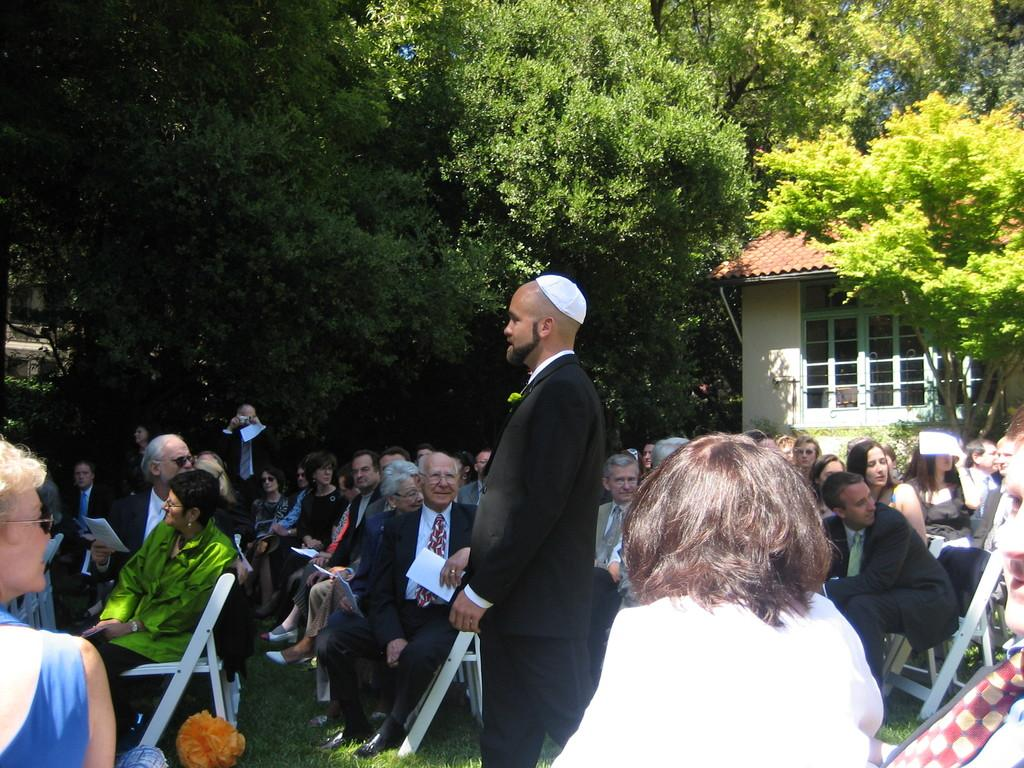What are the people in the image doing? There are people sitting on chairs and standing in the image. What type of surface can be seen under the people's feet? There is grass visible in the image. What can be seen in the distance behind the people? There is a house and trees in the background. What type of rail is visible in the image? There is no rail present in the image. What agreement was reached by the people in the image? The image does not provide any information about an agreement between the people. 